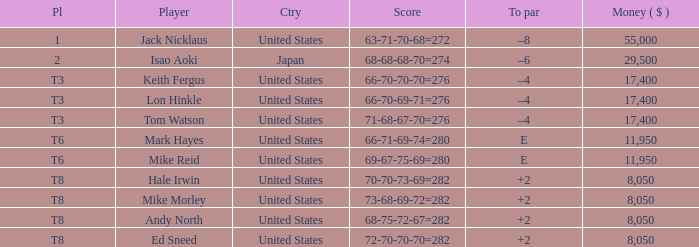What to par is located in the united states and has the player by the name of hale irwin? 2.0. 